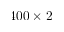Convert formula to latex. <formula><loc_0><loc_0><loc_500><loc_500>4 0 0 \times 2</formula> 